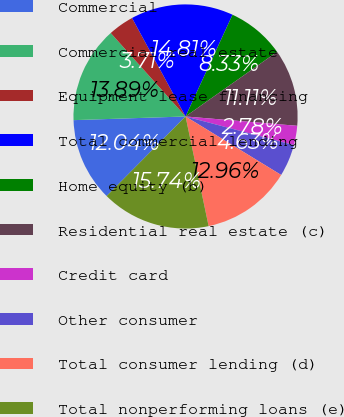Convert chart. <chart><loc_0><loc_0><loc_500><loc_500><pie_chart><fcel>Commercial<fcel>Commercial real estate<fcel>Equipment lease financing<fcel>Total commercial lending<fcel>Home equity (b)<fcel>Residential real estate (c)<fcel>Credit card<fcel>Other consumer<fcel>Total consumer lending (d)<fcel>Total nonperforming loans (e)<nl><fcel>12.04%<fcel>13.89%<fcel>3.71%<fcel>14.81%<fcel>8.33%<fcel>11.11%<fcel>2.78%<fcel>4.63%<fcel>12.96%<fcel>15.74%<nl></chart> 